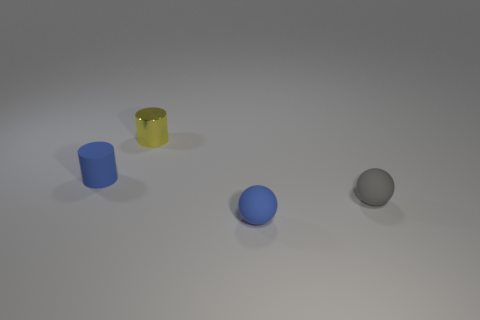Add 4 tiny purple matte cubes. How many objects exist? 8 Subtract all yellow balls. Subtract all gray cubes. How many balls are left? 2 Subtract 0 purple cubes. How many objects are left? 4 Subtract all small cylinders. Subtract all tiny gray balls. How many objects are left? 1 Add 4 yellow metallic cylinders. How many yellow metallic cylinders are left? 5 Add 2 yellow shiny cylinders. How many yellow shiny cylinders exist? 3 